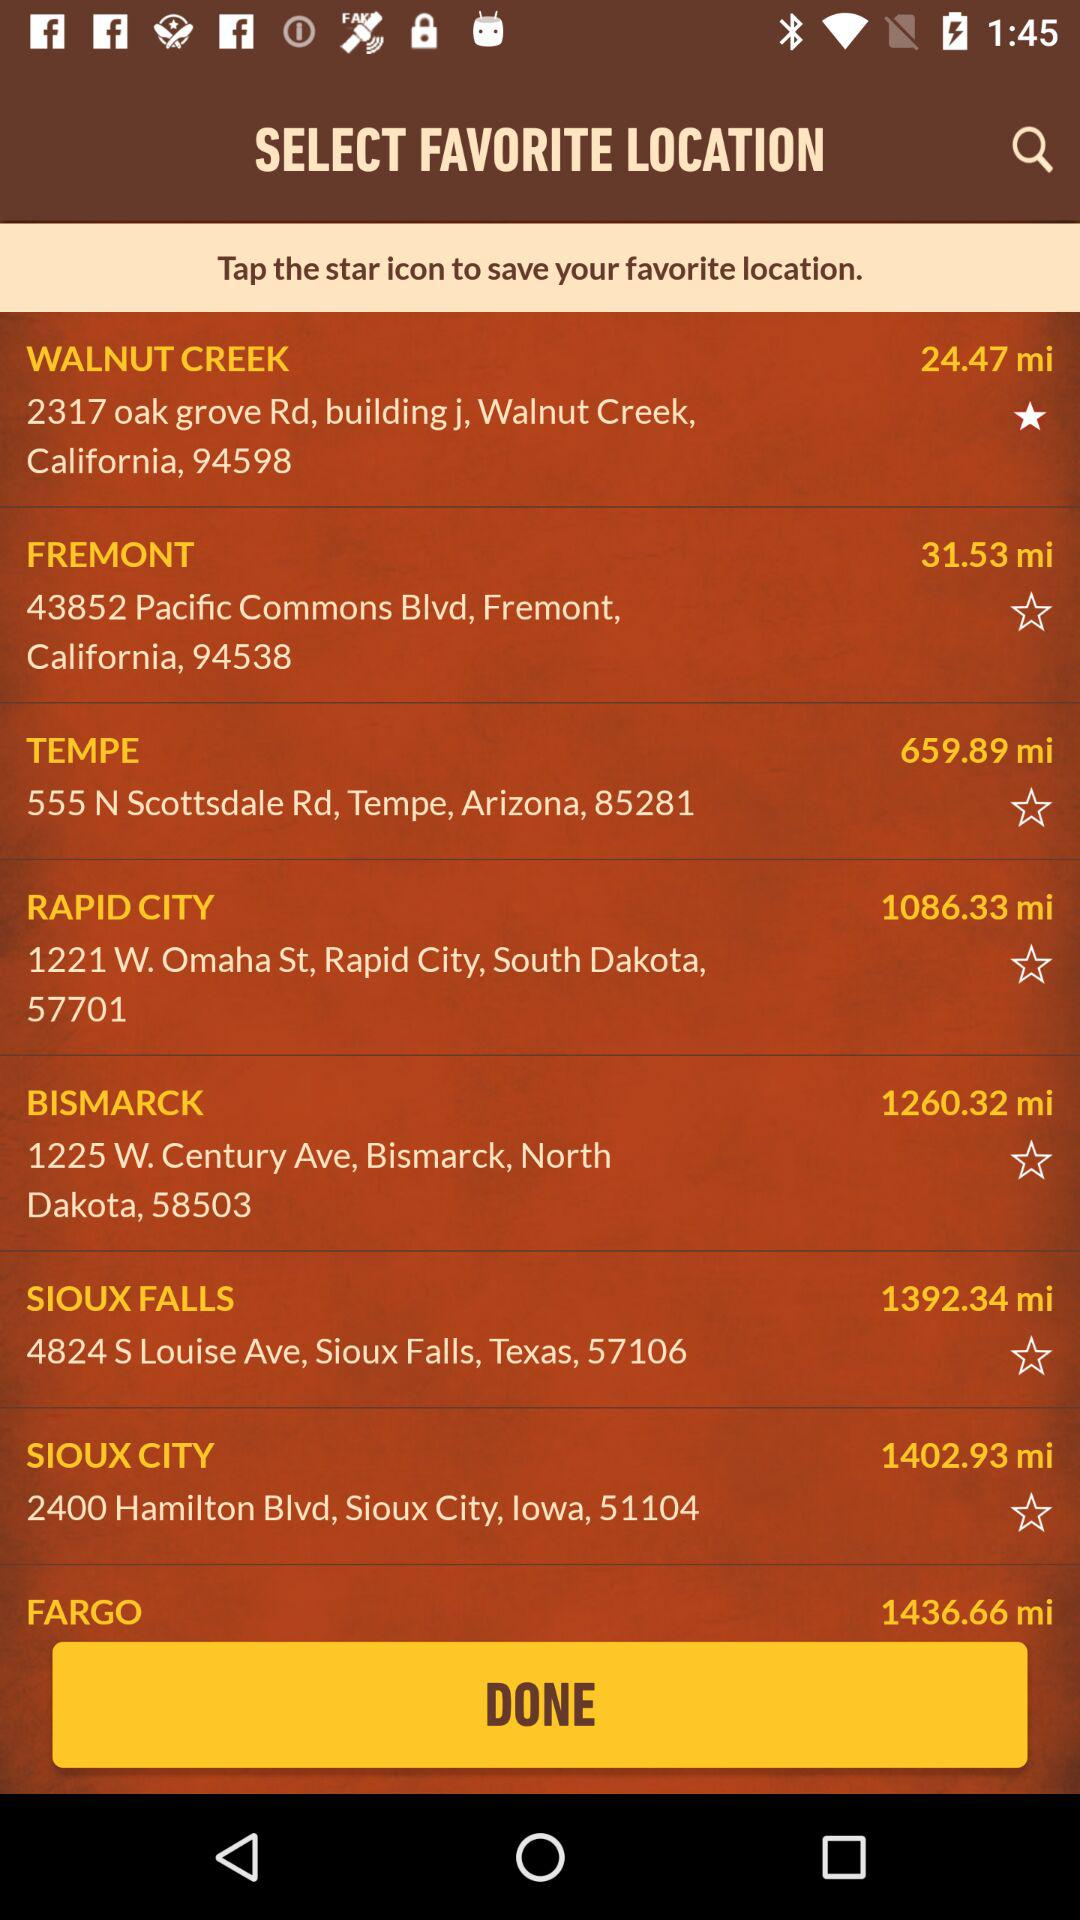How many miles away is Bismarck? Bismarck is 1260.32 miles away. 